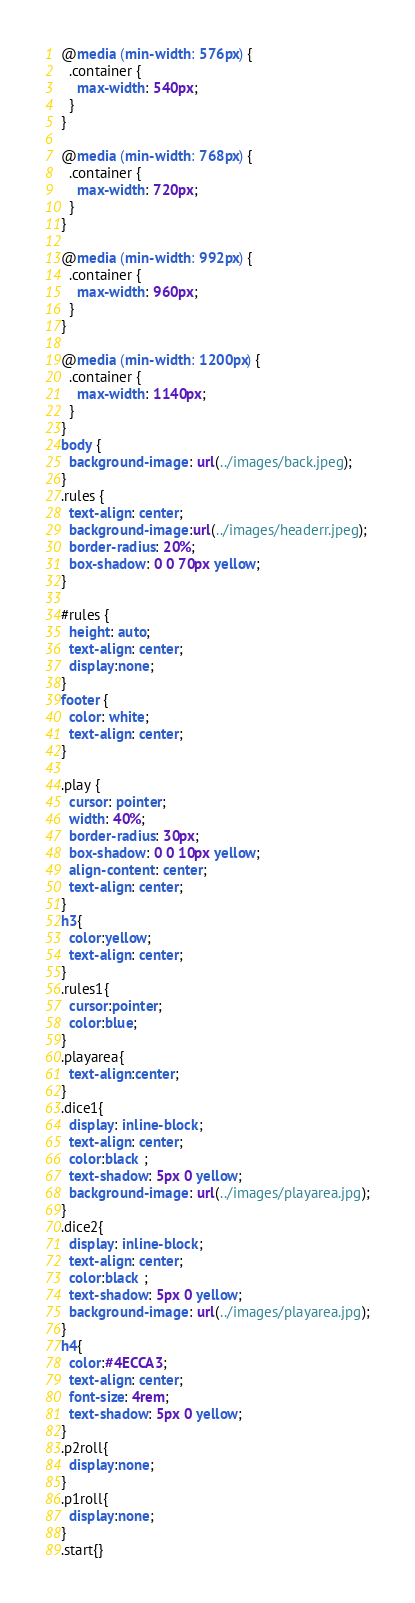Convert code to text. <code><loc_0><loc_0><loc_500><loc_500><_CSS_>@media (min-width: 576px) {
  .container {
    max-width: 540px;
  }
}

@media (min-width: 768px) {
  .container {
    max-width: 720px;
  }
}

@media (min-width: 992px) {
  .container {
    max-width: 960px;
  }
}

@media (min-width: 1200px) {
  .container {
    max-width: 1140px;
  }
}
body {
  background-image: url(../images/back.jpeg);
}
.rules {
  text-align: center;
  background-image:url(../images/headerr.jpeg);
  border-radius: 20%;
  box-shadow: 0 0 70px yellow;
}

#rules {
  height: auto;
  text-align: center;
  display:none;
}
footer {
  color: white;
  text-align: center;
}

.play {
  cursor: pointer;
  width: 40%;
  border-radius: 30px;
  box-shadow: 0 0 10px yellow;
  align-content: center;
  text-align: center;
}
h3{
  color:yellow;
  text-align: center;
}
.rules1{
  cursor:pointer;
  color:blue;
}
.playarea{
  text-align:center;
}
.dice1{
  display: inline-block;
  text-align: center;
  color:black ;
  text-shadow: 5px 0 yellow;
  background-image: url(../images/playarea.jpg);
}
.dice2{
  display: inline-block;
  text-align: center;
  color:black ;
  text-shadow: 5px 0 yellow;
  background-image: url(../images/playarea.jpg);
}
h4{
  color:#4ECCA3;
  text-align: center;
  font-size: 4rem;
  text-shadow: 5px 0 yellow;
}
.p2roll{
  display:none;
}
.p1roll{
  display:none;
}
.start{}
</code> 